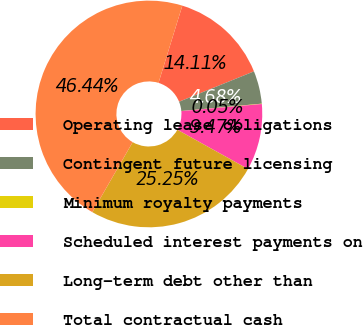<chart> <loc_0><loc_0><loc_500><loc_500><pie_chart><fcel>Operating lease obligations<fcel>Contingent future licensing<fcel>Minimum royalty payments<fcel>Scheduled interest payments on<fcel>Long-term debt other than<fcel>Total contractual cash<nl><fcel>14.11%<fcel>4.68%<fcel>0.05%<fcel>9.47%<fcel>25.25%<fcel>46.44%<nl></chart> 